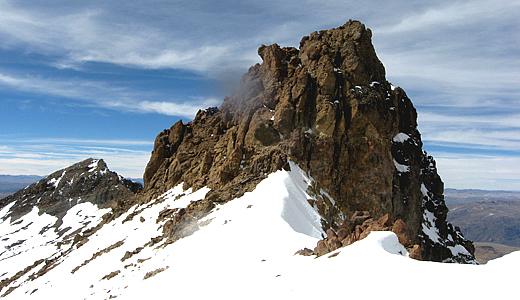Can you tell me more about the climactic conditions one might experience at Nevado Mismi? At Nevado Mismi, climbers can expect a mix of weather conditions typical of high-altitude Andean peaks. Temperatures are generally cold, often dropping below freezing, particularly at night. Snow and ice are prevalent near the summit, and climbers should be prepared for sudden weather changes, including snowstorms. The thin air makes for a lower concentration of oxygen, posing a challenge to those not acclimated to high altitudes. Winds can be strong and biting, further reducing the apparent temperature. Despite the potentially harsh conditions, periods of clear, calm weather with stunning blue skies can provide awe-inspiring moments of tranquility and beauty. What's the best time of year to visit Nevado Mismi for climbing? The best time to visit Nevado Mismi for climbing is during the dry season, which typically runs from May to September. During these months, the weather is more stable, with fewer chances of rain or snowstorms, and the skies are generally clearer, offering better visibility. This period also coincides with Peru's winter, so temperatures are cooler, but the reduced risk of precipitation and more predictable conditions make for a safer and more enjoyable climbing experience. It's crucial to prepare adequately for the cold and high-altitude conditions, regardless of the time of year. Imagine a mysterious creature lives on Nevado Mismi. What would it look like and how does it adapt to its environment? Imagine a fantastical, mythical creature known as the 'Andean Snow Gryphon' residing on Nevado Mismi. This creature boasts a stunning blend of eagle and mountain lion features. Its body is muscular and insulated with thick, snow-white fur, allowing it to withstand freezing temperatures. The face and fierce talons resemble that of a gigantic eagle, with sharp, golden eyes capable of seeing over long distances and navigating through snowstorms. It has powerful, leathery wings adapted for soaring through thin mountain air, and its claws are perfectly designed to gain traction on the icy, rocky outcrops. The creature's fur changes color with the seasons for camouflage - pure white in snowy times and mottled browns in warmer months. This majestic being is a guardian of the Andes peaks, its legend etched into local folklore. 